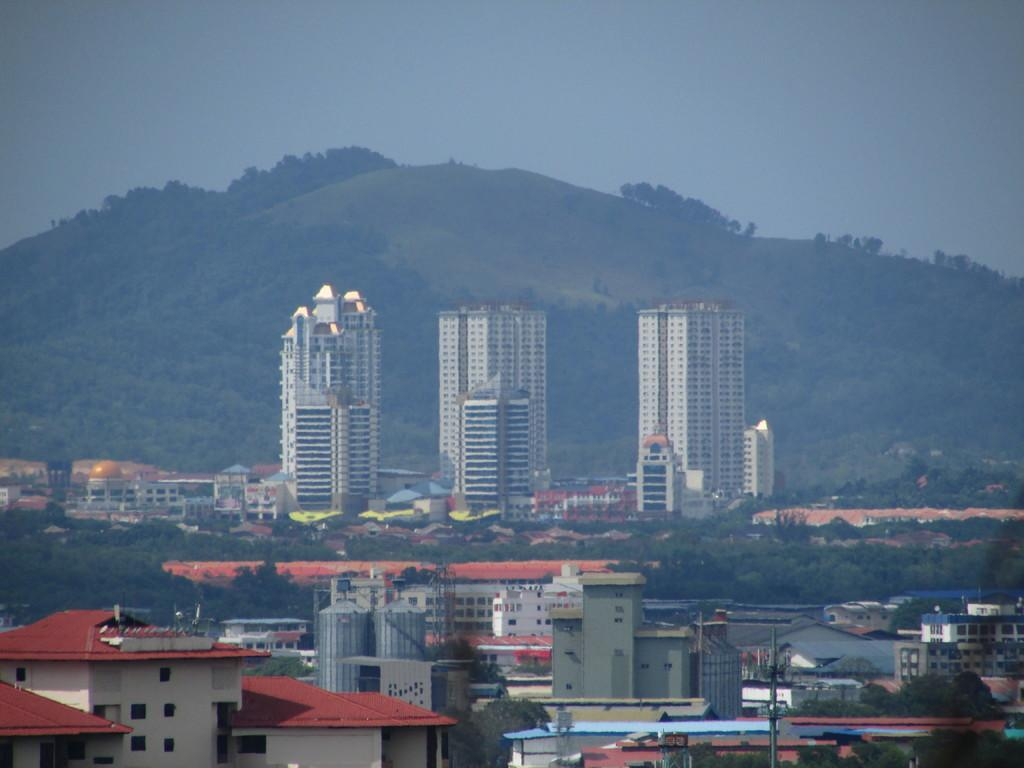What type of structures can be seen in the image? There are houses and buildings in the image. What other natural elements are present in the image? There are trees and a hill in the image. What can be seen in the background of the image? The sky is visible in the background of the image. How many cakes are being served on the tramp in the image? There is no tramp or cakes present in the image. 